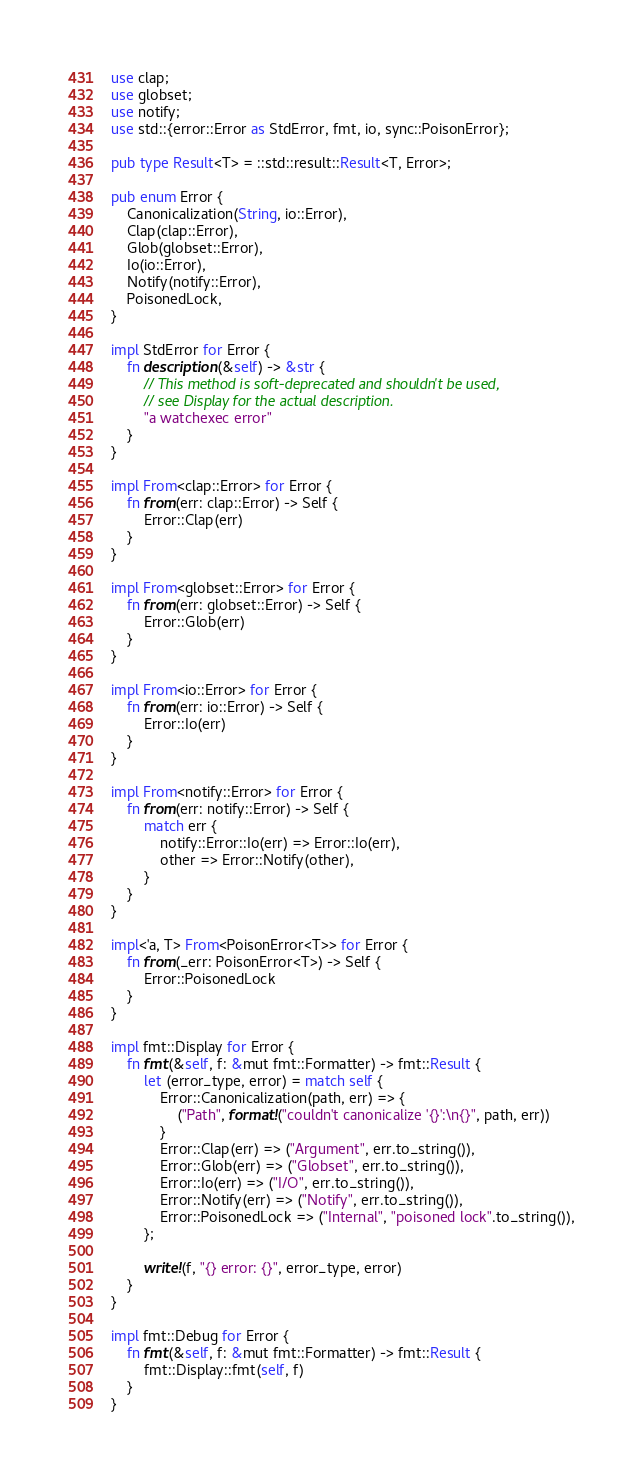<code> <loc_0><loc_0><loc_500><loc_500><_Rust_>use clap;
use globset;
use notify;
use std::{error::Error as StdError, fmt, io, sync::PoisonError};

pub type Result<T> = ::std::result::Result<T, Error>;

pub enum Error {
    Canonicalization(String, io::Error),
    Clap(clap::Error),
    Glob(globset::Error),
    Io(io::Error),
    Notify(notify::Error),
    PoisonedLock,
}

impl StdError for Error {
    fn description(&self) -> &str {
        // This method is soft-deprecated and shouldn't be used,
        // see Display for the actual description.
        "a watchexec error"
    }
}

impl From<clap::Error> for Error {
    fn from(err: clap::Error) -> Self {
        Error::Clap(err)
    }
}

impl From<globset::Error> for Error {
    fn from(err: globset::Error) -> Self {
        Error::Glob(err)
    }
}

impl From<io::Error> for Error {
    fn from(err: io::Error) -> Self {
        Error::Io(err)
    }
}

impl From<notify::Error> for Error {
    fn from(err: notify::Error) -> Self {
        match err {
            notify::Error::Io(err) => Error::Io(err),
            other => Error::Notify(other),
        }
    }
}

impl<'a, T> From<PoisonError<T>> for Error {
    fn from(_err: PoisonError<T>) -> Self {
        Error::PoisonedLock
    }
}

impl fmt::Display for Error {
    fn fmt(&self, f: &mut fmt::Formatter) -> fmt::Result {
        let (error_type, error) = match self {
            Error::Canonicalization(path, err) => {
                ("Path", format!("couldn't canonicalize '{}':\n{}", path, err))
            }
            Error::Clap(err) => ("Argument", err.to_string()),
            Error::Glob(err) => ("Globset", err.to_string()),
            Error::Io(err) => ("I/O", err.to_string()),
            Error::Notify(err) => ("Notify", err.to_string()),
            Error::PoisonedLock => ("Internal", "poisoned lock".to_string()),
        };

        write!(f, "{} error: {}", error_type, error)
    }
}

impl fmt::Debug for Error {
    fn fmt(&self, f: &mut fmt::Formatter) -> fmt::Result {
        fmt::Display::fmt(self, f)
    }
}
</code> 